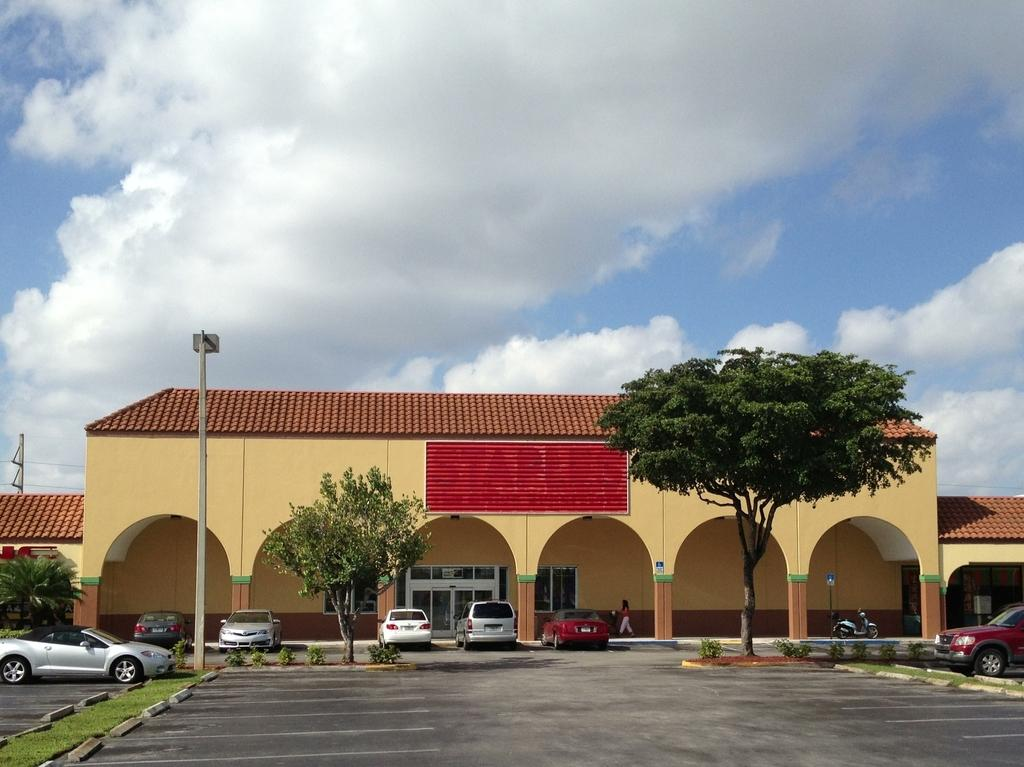What type of structure is visible in the image? There is a building in the image. What can be seen in front of the building? There are vehicles parked in front of the building and trees. What type of locket is hanging from the tree in the image? There is no locket present in the image; it only features a building, vehicles, and trees. 